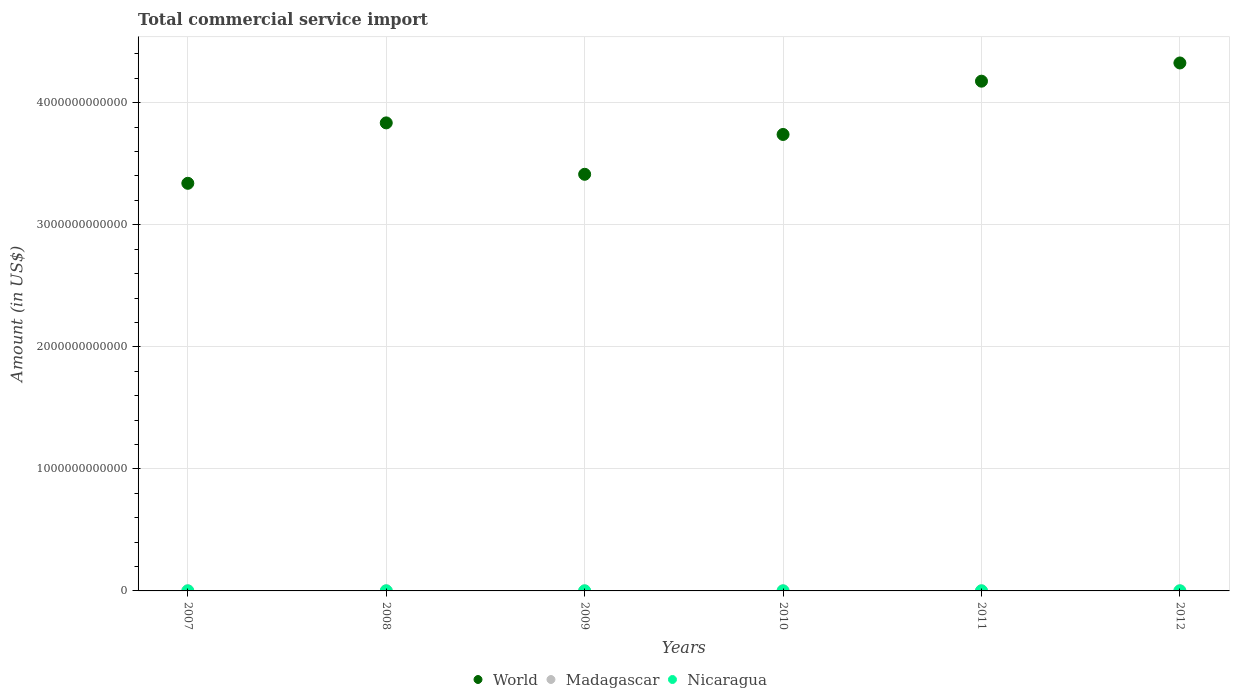What is the total commercial service import in Nicaragua in 2008?
Your answer should be very brief. 8.04e+08. Across all years, what is the maximum total commercial service import in World?
Provide a short and direct response. 4.33e+12. Across all years, what is the minimum total commercial service import in World?
Make the answer very short. 3.34e+12. In which year was the total commercial service import in World minimum?
Keep it short and to the point. 2007. What is the total total commercial service import in Madagascar in the graph?
Offer a very short reply. 6.83e+09. What is the difference between the total commercial service import in World in 2009 and that in 2010?
Provide a succinct answer. -3.26e+11. What is the difference between the total commercial service import in Madagascar in 2009 and the total commercial service import in Nicaragua in 2010?
Your answer should be compact. 4.34e+08. What is the average total commercial service import in World per year?
Your answer should be compact. 3.81e+12. In the year 2007, what is the difference between the total commercial service import in Madagascar and total commercial service import in Nicaragua?
Keep it short and to the point. 3.45e+08. In how many years, is the total commercial service import in World greater than 3600000000000 US$?
Give a very brief answer. 4. What is the ratio of the total commercial service import in Nicaragua in 2008 to that in 2009?
Provide a succinct answer. 1.15. Is the total commercial service import in Madagascar in 2011 less than that in 2012?
Offer a terse response. No. What is the difference between the highest and the second highest total commercial service import in Nicaragua?
Your answer should be compact. 4.55e+07. What is the difference between the highest and the lowest total commercial service import in World?
Keep it short and to the point. 9.86e+11. Is the sum of the total commercial service import in World in 2011 and 2012 greater than the maximum total commercial service import in Nicaragua across all years?
Keep it short and to the point. Yes. Is it the case that in every year, the sum of the total commercial service import in Madagascar and total commercial service import in World  is greater than the total commercial service import in Nicaragua?
Give a very brief answer. Yes. Does the total commercial service import in Nicaragua monotonically increase over the years?
Make the answer very short. No. How many years are there in the graph?
Offer a terse response. 6. What is the difference between two consecutive major ticks on the Y-axis?
Your response must be concise. 1.00e+12. Does the graph contain any zero values?
Ensure brevity in your answer.  No. Does the graph contain grids?
Provide a short and direct response. Yes. How are the legend labels stacked?
Make the answer very short. Horizontal. What is the title of the graph?
Make the answer very short. Total commercial service import. Does "Lower middle income" appear as one of the legend labels in the graph?
Your answer should be compact. No. What is the label or title of the X-axis?
Your response must be concise. Years. What is the label or title of the Y-axis?
Provide a short and direct response. Amount (in US$). What is the Amount (in US$) in World in 2007?
Provide a succinct answer. 3.34e+12. What is the Amount (in US$) in Madagascar in 2007?
Offer a very short reply. 1.00e+09. What is the Amount (in US$) of Nicaragua in 2007?
Give a very brief answer. 6.60e+08. What is the Amount (in US$) in World in 2008?
Give a very brief answer. 3.83e+12. What is the Amount (in US$) in Madagascar in 2008?
Make the answer very short. 1.35e+09. What is the Amount (in US$) in Nicaragua in 2008?
Give a very brief answer. 8.04e+08. What is the Amount (in US$) in World in 2009?
Your response must be concise. 3.41e+12. What is the Amount (in US$) in Madagascar in 2009?
Make the answer very short. 1.11e+09. What is the Amount (in US$) of Nicaragua in 2009?
Offer a very short reply. 6.96e+08. What is the Amount (in US$) of World in 2010?
Your answer should be compact. 3.74e+12. What is the Amount (in US$) in Madagascar in 2010?
Give a very brief answer. 1.10e+09. What is the Amount (in US$) in Nicaragua in 2010?
Make the answer very short. 6.80e+08. What is the Amount (in US$) in World in 2011?
Offer a very short reply. 4.18e+12. What is the Amount (in US$) in Madagascar in 2011?
Provide a succinct answer. 1.14e+09. What is the Amount (in US$) of Nicaragua in 2011?
Offer a very short reply. 8.05e+08. What is the Amount (in US$) of World in 2012?
Your answer should be very brief. 4.33e+12. What is the Amount (in US$) of Madagascar in 2012?
Provide a succinct answer. 1.12e+09. What is the Amount (in US$) in Nicaragua in 2012?
Your answer should be compact. 8.51e+08. Across all years, what is the maximum Amount (in US$) in World?
Your response must be concise. 4.33e+12. Across all years, what is the maximum Amount (in US$) of Madagascar?
Provide a short and direct response. 1.35e+09. Across all years, what is the maximum Amount (in US$) in Nicaragua?
Offer a very short reply. 8.51e+08. Across all years, what is the minimum Amount (in US$) of World?
Your response must be concise. 3.34e+12. Across all years, what is the minimum Amount (in US$) of Madagascar?
Offer a terse response. 1.00e+09. Across all years, what is the minimum Amount (in US$) in Nicaragua?
Your response must be concise. 6.60e+08. What is the total Amount (in US$) of World in the graph?
Your response must be concise. 2.28e+13. What is the total Amount (in US$) in Madagascar in the graph?
Your answer should be compact. 6.83e+09. What is the total Amount (in US$) of Nicaragua in the graph?
Keep it short and to the point. 4.50e+09. What is the difference between the Amount (in US$) in World in 2007 and that in 2008?
Your response must be concise. -4.95e+11. What is the difference between the Amount (in US$) in Madagascar in 2007 and that in 2008?
Give a very brief answer. -3.45e+08. What is the difference between the Amount (in US$) of Nicaragua in 2007 and that in 2008?
Your answer should be very brief. -1.43e+08. What is the difference between the Amount (in US$) in World in 2007 and that in 2009?
Offer a terse response. -7.39e+1. What is the difference between the Amount (in US$) in Madagascar in 2007 and that in 2009?
Provide a short and direct response. -1.09e+08. What is the difference between the Amount (in US$) in Nicaragua in 2007 and that in 2009?
Provide a succinct answer. -3.56e+07. What is the difference between the Amount (in US$) in World in 2007 and that in 2010?
Ensure brevity in your answer.  -4.00e+11. What is the difference between the Amount (in US$) in Madagascar in 2007 and that in 2010?
Give a very brief answer. -9.25e+07. What is the difference between the Amount (in US$) in Nicaragua in 2007 and that in 2010?
Offer a very short reply. -2.00e+07. What is the difference between the Amount (in US$) of World in 2007 and that in 2011?
Your response must be concise. -8.37e+11. What is the difference between the Amount (in US$) of Madagascar in 2007 and that in 2011?
Make the answer very short. -1.39e+08. What is the difference between the Amount (in US$) of Nicaragua in 2007 and that in 2011?
Your answer should be very brief. -1.45e+08. What is the difference between the Amount (in US$) in World in 2007 and that in 2012?
Offer a terse response. -9.86e+11. What is the difference between the Amount (in US$) of Madagascar in 2007 and that in 2012?
Your response must be concise. -1.13e+08. What is the difference between the Amount (in US$) of Nicaragua in 2007 and that in 2012?
Your response must be concise. -1.91e+08. What is the difference between the Amount (in US$) in World in 2008 and that in 2009?
Give a very brief answer. 4.21e+11. What is the difference between the Amount (in US$) in Madagascar in 2008 and that in 2009?
Offer a terse response. 2.36e+08. What is the difference between the Amount (in US$) in Nicaragua in 2008 and that in 2009?
Ensure brevity in your answer.  1.08e+08. What is the difference between the Amount (in US$) in World in 2008 and that in 2010?
Offer a very short reply. 9.48e+1. What is the difference between the Amount (in US$) in Madagascar in 2008 and that in 2010?
Keep it short and to the point. 2.53e+08. What is the difference between the Amount (in US$) of Nicaragua in 2008 and that in 2010?
Keep it short and to the point. 1.23e+08. What is the difference between the Amount (in US$) in World in 2008 and that in 2011?
Your answer should be compact. -3.42e+11. What is the difference between the Amount (in US$) of Madagascar in 2008 and that in 2011?
Provide a succinct answer. 2.07e+08. What is the difference between the Amount (in US$) in Nicaragua in 2008 and that in 2011?
Offer a terse response. -1.80e+06. What is the difference between the Amount (in US$) in World in 2008 and that in 2012?
Your response must be concise. -4.91e+11. What is the difference between the Amount (in US$) of Madagascar in 2008 and that in 2012?
Your answer should be very brief. 2.32e+08. What is the difference between the Amount (in US$) of Nicaragua in 2008 and that in 2012?
Offer a very short reply. -4.73e+07. What is the difference between the Amount (in US$) of World in 2009 and that in 2010?
Keep it short and to the point. -3.26e+11. What is the difference between the Amount (in US$) of Madagascar in 2009 and that in 2010?
Keep it short and to the point. 1.64e+07. What is the difference between the Amount (in US$) in Nicaragua in 2009 and that in 2010?
Offer a very short reply. 1.56e+07. What is the difference between the Amount (in US$) of World in 2009 and that in 2011?
Your response must be concise. -7.63e+11. What is the difference between the Amount (in US$) of Madagascar in 2009 and that in 2011?
Offer a terse response. -2.98e+07. What is the difference between the Amount (in US$) of Nicaragua in 2009 and that in 2011?
Your response must be concise. -1.10e+08. What is the difference between the Amount (in US$) of World in 2009 and that in 2012?
Your response must be concise. -9.12e+11. What is the difference between the Amount (in US$) in Madagascar in 2009 and that in 2012?
Ensure brevity in your answer.  -4.01e+06. What is the difference between the Amount (in US$) in Nicaragua in 2009 and that in 2012?
Offer a very short reply. -1.55e+08. What is the difference between the Amount (in US$) in World in 2010 and that in 2011?
Your answer should be very brief. -4.37e+11. What is the difference between the Amount (in US$) in Madagascar in 2010 and that in 2011?
Keep it short and to the point. -4.62e+07. What is the difference between the Amount (in US$) in Nicaragua in 2010 and that in 2011?
Make the answer very short. -1.25e+08. What is the difference between the Amount (in US$) in World in 2010 and that in 2012?
Your answer should be compact. -5.86e+11. What is the difference between the Amount (in US$) in Madagascar in 2010 and that in 2012?
Provide a succinct answer. -2.04e+07. What is the difference between the Amount (in US$) in Nicaragua in 2010 and that in 2012?
Provide a succinct answer. -1.71e+08. What is the difference between the Amount (in US$) of World in 2011 and that in 2012?
Keep it short and to the point. -1.49e+11. What is the difference between the Amount (in US$) of Madagascar in 2011 and that in 2012?
Keep it short and to the point. 2.58e+07. What is the difference between the Amount (in US$) in Nicaragua in 2011 and that in 2012?
Your response must be concise. -4.55e+07. What is the difference between the Amount (in US$) in World in 2007 and the Amount (in US$) in Madagascar in 2008?
Provide a succinct answer. 3.34e+12. What is the difference between the Amount (in US$) of World in 2007 and the Amount (in US$) of Nicaragua in 2008?
Offer a very short reply. 3.34e+12. What is the difference between the Amount (in US$) of Madagascar in 2007 and the Amount (in US$) of Nicaragua in 2008?
Make the answer very short. 2.01e+08. What is the difference between the Amount (in US$) in World in 2007 and the Amount (in US$) in Madagascar in 2009?
Ensure brevity in your answer.  3.34e+12. What is the difference between the Amount (in US$) of World in 2007 and the Amount (in US$) of Nicaragua in 2009?
Give a very brief answer. 3.34e+12. What is the difference between the Amount (in US$) of Madagascar in 2007 and the Amount (in US$) of Nicaragua in 2009?
Give a very brief answer. 3.09e+08. What is the difference between the Amount (in US$) in World in 2007 and the Amount (in US$) in Madagascar in 2010?
Ensure brevity in your answer.  3.34e+12. What is the difference between the Amount (in US$) of World in 2007 and the Amount (in US$) of Nicaragua in 2010?
Your answer should be very brief. 3.34e+12. What is the difference between the Amount (in US$) in Madagascar in 2007 and the Amount (in US$) in Nicaragua in 2010?
Your response must be concise. 3.25e+08. What is the difference between the Amount (in US$) in World in 2007 and the Amount (in US$) in Madagascar in 2011?
Provide a succinct answer. 3.34e+12. What is the difference between the Amount (in US$) in World in 2007 and the Amount (in US$) in Nicaragua in 2011?
Give a very brief answer. 3.34e+12. What is the difference between the Amount (in US$) of Madagascar in 2007 and the Amount (in US$) of Nicaragua in 2011?
Your answer should be compact. 2.00e+08. What is the difference between the Amount (in US$) in World in 2007 and the Amount (in US$) in Madagascar in 2012?
Make the answer very short. 3.34e+12. What is the difference between the Amount (in US$) of World in 2007 and the Amount (in US$) of Nicaragua in 2012?
Your response must be concise. 3.34e+12. What is the difference between the Amount (in US$) in Madagascar in 2007 and the Amount (in US$) in Nicaragua in 2012?
Offer a very short reply. 1.54e+08. What is the difference between the Amount (in US$) in World in 2008 and the Amount (in US$) in Madagascar in 2009?
Offer a very short reply. 3.83e+12. What is the difference between the Amount (in US$) of World in 2008 and the Amount (in US$) of Nicaragua in 2009?
Make the answer very short. 3.83e+12. What is the difference between the Amount (in US$) in Madagascar in 2008 and the Amount (in US$) in Nicaragua in 2009?
Provide a succinct answer. 6.54e+08. What is the difference between the Amount (in US$) in World in 2008 and the Amount (in US$) in Madagascar in 2010?
Provide a succinct answer. 3.83e+12. What is the difference between the Amount (in US$) of World in 2008 and the Amount (in US$) of Nicaragua in 2010?
Your answer should be compact. 3.83e+12. What is the difference between the Amount (in US$) of Madagascar in 2008 and the Amount (in US$) of Nicaragua in 2010?
Make the answer very short. 6.70e+08. What is the difference between the Amount (in US$) of World in 2008 and the Amount (in US$) of Madagascar in 2011?
Offer a very short reply. 3.83e+12. What is the difference between the Amount (in US$) in World in 2008 and the Amount (in US$) in Nicaragua in 2011?
Provide a succinct answer. 3.83e+12. What is the difference between the Amount (in US$) of Madagascar in 2008 and the Amount (in US$) of Nicaragua in 2011?
Give a very brief answer. 5.45e+08. What is the difference between the Amount (in US$) in World in 2008 and the Amount (in US$) in Madagascar in 2012?
Give a very brief answer. 3.83e+12. What is the difference between the Amount (in US$) of World in 2008 and the Amount (in US$) of Nicaragua in 2012?
Your response must be concise. 3.83e+12. What is the difference between the Amount (in US$) in Madagascar in 2008 and the Amount (in US$) in Nicaragua in 2012?
Your response must be concise. 4.99e+08. What is the difference between the Amount (in US$) of World in 2009 and the Amount (in US$) of Madagascar in 2010?
Provide a short and direct response. 3.41e+12. What is the difference between the Amount (in US$) in World in 2009 and the Amount (in US$) in Nicaragua in 2010?
Offer a very short reply. 3.41e+12. What is the difference between the Amount (in US$) of Madagascar in 2009 and the Amount (in US$) of Nicaragua in 2010?
Make the answer very short. 4.34e+08. What is the difference between the Amount (in US$) in World in 2009 and the Amount (in US$) in Madagascar in 2011?
Provide a succinct answer. 3.41e+12. What is the difference between the Amount (in US$) of World in 2009 and the Amount (in US$) of Nicaragua in 2011?
Offer a terse response. 3.41e+12. What is the difference between the Amount (in US$) of Madagascar in 2009 and the Amount (in US$) of Nicaragua in 2011?
Provide a short and direct response. 3.08e+08. What is the difference between the Amount (in US$) in World in 2009 and the Amount (in US$) in Madagascar in 2012?
Make the answer very short. 3.41e+12. What is the difference between the Amount (in US$) in World in 2009 and the Amount (in US$) in Nicaragua in 2012?
Your answer should be very brief. 3.41e+12. What is the difference between the Amount (in US$) in Madagascar in 2009 and the Amount (in US$) in Nicaragua in 2012?
Your answer should be very brief. 2.63e+08. What is the difference between the Amount (in US$) of World in 2010 and the Amount (in US$) of Madagascar in 2011?
Keep it short and to the point. 3.74e+12. What is the difference between the Amount (in US$) of World in 2010 and the Amount (in US$) of Nicaragua in 2011?
Your answer should be very brief. 3.74e+12. What is the difference between the Amount (in US$) of Madagascar in 2010 and the Amount (in US$) of Nicaragua in 2011?
Your answer should be very brief. 2.92e+08. What is the difference between the Amount (in US$) in World in 2010 and the Amount (in US$) in Madagascar in 2012?
Give a very brief answer. 3.74e+12. What is the difference between the Amount (in US$) in World in 2010 and the Amount (in US$) in Nicaragua in 2012?
Ensure brevity in your answer.  3.74e+12. What is the difference between the Amount (in US$) in Madagascar in 2010 and the Amount (in US$) in Nicaragua in 2012?
Offer a very short reply. 2.47e+08. What is the difference between the Amount (in US$) of World in 2011 and the Amount (in US$) of Madagascar in 2012?
Offer a terse response. 4.18e+12. What is the difference between the Amount (in US$) of World in 2011 and the Amount (in US$) of Nicaragua in 2012?
Offer a very short reply. 4.18e+12. What is the difference between the Amount (in US$) in Madagascar in 2011 and the Amount (in US$) in Nicaragua in 2012?
Keep it short and to the point. 2.93e+08. What is the average Amount (in US$) in World per year?
Offer a terse response. 3.81e+12. What is the average Amount (in US$) of Madagascar per year?
Your response must be concise. 1.14e+09. What is the average Amount (in US$) of Nicaragua per year?
Give a very brief answer. 7.49e+08. In the year 2007, what is the difference between the Amount (in US$) of World and Amount (in US$) of Madagascar?
Make the answer very short. 3.34e+12. In the year 2007, what is the difference between the Amount (in US$) of World and Amount (in US$) of Nicaragua?
Offer a very short reply. 3.34e+12. In the year 2007, what is the difference between the Amount (in US$) of Madagascar and Amount (in US$) of Nicaragua?
Give a very brief answer. 3.45e+08. In the year 2008, what is the difference between the Amount (in US$) of World and Amount (in US$) of Madagascar?
Your answer should be very brief. 3.83e+12. In the year 2008, what is the difference between the Amount (in US$) of World and Amount (in US$) of Nicaragua?
Make the answer very short. 3.83e+12. In the year 2008, what is the difference between the Amount (in US$) in Madagascar and Amount (in US$) in Nicaragua?
Provide a short and direct response. 5.47e+08. In the year 2009, what is the difference between the Amount (in US$) of World and Amount (in US$) of Madagascar?
Your answer should be very brief. 3.41e+12. In the year 2009, what is the difference between the Amount (in US$) of World and Amount (in US$) of Nicaragua?
Keep it short and to the point. 3.41e+12. In the year 2009, what is the difference between the Amount (in US$) in Madagascar and Amount (in US$) in Nicaragua?
Ensure brevity in your answer.  4.18e+08. In the year 2010, what is the difference between the Amount (in US$) of World and Amount (in US$) of Madagascar?
Offer a very short reply. 3.74e+12. In the year 2010, what is the difference between the Amount (in US$) in World and Amount (in US$) in Nicaragua?
Offer a terse response. 3.74e+12. In the year 2010, what is the difference between the Amount (in US$) of Madagascar and Amount (in US$) of Nicaragua?
Your answer should be compact. 4.17e+08. In the year 2011, what is the difference between the Amount (in US$) of World and Amount (in US$) of Madagascar?
Your response must be concise. 4.18e+12. In the year 2011, what is the difference between the Amount (in US$) of World and Amount (in US$) of Nicaragua?
Keep it short and to the point. 4.18e+12. In the year 2011, what is the difference between the Amount (in US$) of Madagascar and Amount (in US$) of Nicaragua?
Your response must be concise. 3.38e+08. In the year 2012, what is the difference between the Amount (in US$) in World and Amount (in US$) in Madagascar?
Your response must be concise. 4.32e+12. In the year 2012, what is the difference between the Amount (in US$) in World and Amount (in US$) in Nicaragua?
Ensure brevity in your answer.  4.32e+12. In the year 2012, what is the difference between the Amount (in US$) of Madagascar and Amount (in US$) of Nicaragua?
Offer a very short reply. 2.67e+08. What is the ratio of the Amount (in US$) of World in 2007 to that in 2008?
Offer a terse response. 0.87. What is the ratio of the Amount (in US$) in Madagascar in 2007 to that in 2008?
Your answer should be compact. 0.74. What is the ratio of the Amount (in US$) of Nicaragua in 2007 to that in 2008?
Give a very brief answer. 0.82. What is the ratio of the Amount (in US$) in World in 2007 to that in 2009?
Your answer should be compact. 0.98. What is the ratio of the Amount (in US$) of Madagascar in 2007 to that in 2009?
Provide a succinct answer. 0.9. What is the ratio of the Amount (in US$) in Nicaragua in 2007 to that in 2009?
Offer a very short reply. 0.95. What is the ratio of the Amount (in US$) in World in 2007 to that in 2010?
Your answer should be compact. 0.89. What is the ratio of the Amount (in US$) of Madagascar in 2007 to that in 2010?
Ensure brevity in your answer.  0.92. What is the ratio of the Amount (in US$) in Nicaragua in 2007 to that in 2010?
Offer a very short reply. 0.97. What is the ratio of the Amount (in US$) in World in 2007 to that in 2011?
Provide a succinct answer. 0.8. What is the ratio of the Amount (in US$) of Madagascar in 2007 to that in 2011?
Ensure brevity in your answer.  0.88. What is the ratio of the Amount (in US$) in Nicaragua in 2007 to that in 2011?
Offer a very short reply. 0.82. What is the ratio of the Amount (in US$) in World in 2007 to that in 2012?
Your response must be concise. 0.77. What is the ratio of the Amount (in US$) of Madagascar in 2007 to that in 2012?
Make the answer very short. 0.9. What is the ratio of the Amount (in US$) in Nicaragua in 2007 to that in 2012?
Provide a succinct answer. 0.78. What is the ratio of the Amount (in US$) of World in 2008 to that in 2009?
Offer a very short reply. 1.12. What is the ratio of the Amount (in US$) of Madagascar in 2008 to that in 2009?
Keep it short and to the point. 1.21. What is the ratio of the Amount (in US$) in Nicaragua in 2008 to that in 2009?
Offer a very short reply. 1.16. What is the ratio of the Amount (in US$) of World in 2008 to that in 2010?
Provide a short and direct response. 1.03. What is the ratio of the Amount (in US$) in Madagascar in 2008 to that in 2010?
Provide a succinct answer. 1.23. What is the ratio of the Amount (in US$) of Nicaragua in 2008 to that in 2010?
Your answer should be compact. 1.18. What is the ratio of the Amount (in US$) in World in 2008 to that in 2011?
Offer a terse response. 0.92. What is the ratio of the Amount (in US$) of Madagascar in 2008 to that in 2011?
Make the answer very short. 1.18. What is the ratio of the Amount (in US$) in Nicaragua in 2008 to that in 2011?
Your response must be concise. 1. What is the ratio of the Amount (in US$) in World in 2008 to that in 2012?
Provide a short and direct response. 0.89. What is the ratio of the Amount (in US$) in Madagascar in 2008 to that in 2012?
Provide a short and direct response. 1.21. What is the ratio of the Amount (in US$) in World in 2009 to that in 2010?
Make the answer very short. 0.91. What is the ratio of the Amount (in US$) in Madagascar in 2009 to that in 2010?
Your response must be concise. 1.01. What is the ratio of the Amount (in US$) in Nicaragua in 2009 to that in 2010?
Your answer should be very brief. 1.02. What is the ratio of the Amount (in US$) of World in 2009 to that in 2011?
Your answer should be compact. 0.82. What is the ratio of the Amount (in US$) in Madagascar in 2009 to that in 2011?
Give a very brief answer. 0.97. What is the ratio of the Amount (in US$) in Nicaragua in 2009 to that in 2011?
Ensure brevity in your answer.  0.86. What is the ratio of the Amount (in US$) in World in 2009 to that in 2012?
Offer a very short reply. 0.79. What is the ratio of the Amount (in US$) in Madagascar in 2009 to that in 2012?
Make the answer very short. 1. What is the ratio of the Amount (in US$) of Nicaragua in 2009 to that in 2012?
Give a very brief answer. 0.82. What is the ratio of the Amount (in US$) of World in 2010 to that in 2011?
Your answer should be very brief. 0.9. What is the ratio of the Amount (in US$) of Madagascar in 2010 to that in 2011?
Your answer should be compact. 0.96. What is the ratio of the Amount (in US$) of Nicaragua in 2010 to that in 2011?
Offer a terse response. 0.84. What is the ratio of the Amount (in US$) in World in 2010 to that in 2012?
Make the answer very short. 0.86. What is the ratio of the Amount (in US$) in Madagascar in 2010 to that in 2012?
Ensure brevity in your answer.  0.98. What is the ratio of the Amount (in US$) in Nicaragua in 2010 to that in 2012?
Provide a succinct answer. 0.8. What is the ratio of the Amount (in US$) of World in 2011 to that in 2012?
Your response must be concise. 0.97. What is the ratio of the Amount (in US$) in Madagascar in 2011 to that in 2012?
Keep it short and to the point. 1.02. What is the ratio of the Amount (in US$) in Nicaragua in 2011 to that in 2012?
Give a very brief answer. 0.95. What is the difference between the highest and the second highest Amount (in US$) of World?
Provide a short and direct response. 1.49e+11. What is the difference between the highest and the second highest Amount (in US$) of Madagascar?
Ensure brevity in your answer.  2.07e+08. What is the difference between the highest and the second highest Amount (in US$) in Nicaragua?
Offer a very short reply. 4.55e+07. What is the difference between the highest and the lowest Amount (in US$) of World?
Your answer should be very brief. 9.86e+11. What is the difference between the highest and the lowest Amount (in US$) of Madagascar?
Offer a terse response. 3.45e+08. What is the difference between the highest and the lowest Amount (in US$) of Nicaragua?
Keep it short and to the point. 1.91e+08. 